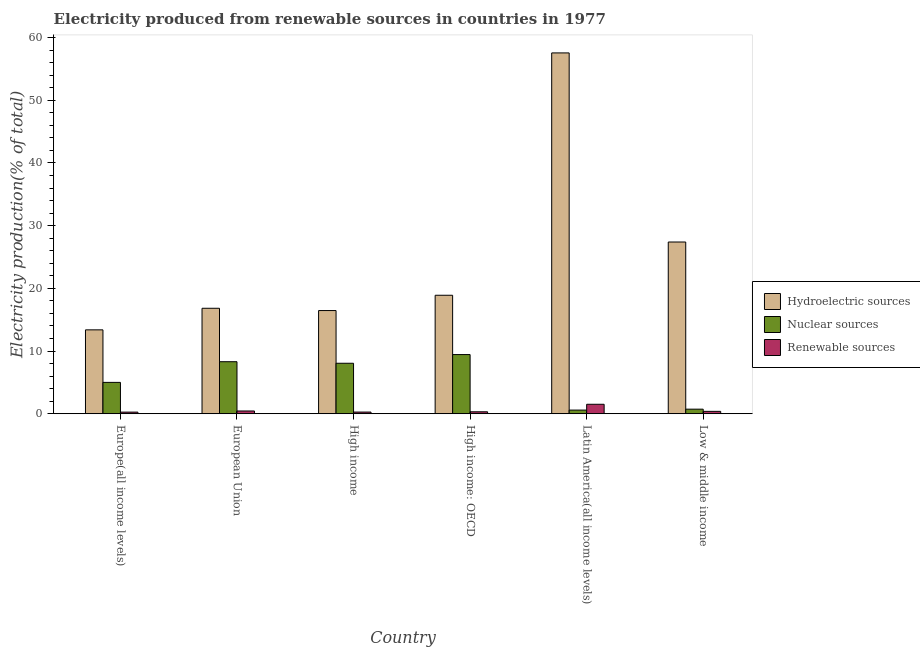How many different coloured bars are there?
Your answer should be compact. 3. How many groups of bars are there?
Keep it short and to the point. 6. Are the number of bars per tick equal to the number of legend labels?
Offer a very short reply. Yes. Are the number of bars on each tick of the X-axis equal?
Your answer should be very brief. Yes. How many bars are there on the 1st tick from the right?
Your answer should be very brief. 3. What is the label of the 5th group of bars from the left?
Make the answer very short. Latin America(all income levels). What is the percentage of electricity produced by nuclear sources in European Union?
Keep it short and to the point. 8.3. Across all countries, what is the maximum percentage of electricity produced by hydroelectric sources?
Offer a very short reply. 57.55. Across all countries, what is the minimum percentage of electricity produced by nuclear sources?
Your response must be concise. 0.58. In which country was the percentage of electricity produced by renewable sources maximum?
Provide a succinct answer. Latin America(all income levels). In which country was the percentage of electricity produced by renewable sources minimum?
Make the answer very short. Europe(all income levels). What is the total percentage of electricity produced by renewable sources in the graph?
Provide a succinct answer. 3.17. What is the difference between the percentage of electricity produced by nuclear sources in European Union and that in High income?
Offer a very short reply. 0.24. What is the difference between the percentage of electricity produced by nuclear sources in High income: OECD and the percentage of electricity produced by hydroelectric sources in Low & middle income?
Your answer should be very brief. -17.95. What is the average percentage of electricity produced by renewable sources per country?
Ensure brevity in your answer.  0.53. What is the difference between the percentage of electricity produced by renewable sources and percentage of electricity produced by nuclear sources in Europe(all income levels)?
Ensure brevity in your answer.  -4.74. What is the ratio of the percentage of electricity produced by hydroelectric sources in Europe(all income levels) to that in High income: OECD?
Your answer should be compact. 0.71. Is the percentage of electricity produced by nuclear sources in European Union less than that in High income: OECD?
Your response must be concise. Yes. What is the difference between the highest and the second highest percentage of electricity produced by renewable sources?
Offer a terse response. 1.07. What is the difference between the highest and the lowest percentage of electricity produced by hydroelectric sources?
Your answer should be very brief. 44.17. In how many countries, is the percentage of electricity produced by renewable sources greater than the average percentage of electricity produced by renewable sources taken over all countries?
Offer a terse response. 1. What does the 1st bar from the left in European Union represents?
Your answer should be very brief. Hydroelectric sources. What does the 1st bar from the right in Low & middle income represents?
Your answer should be very brief. Renewable sources. Is it the case that in every country, the sum of the percentage of electricity produced by hydroelectric sources and percentage of electricity produced by nuclear sources is greater than the percentage of electricity produced by renewable sources?
Your response must be concise. Yes. Are all the bars in the graph horizontal?
Your answer should be compact. No. How many countries are there in the graph?
Provide a succinct answer. 6. What is the difference between two consecutive major ticks on the Y-axis?
Your response must be concise. 10. Are the values on the major ticks of Y-axis written in scientific E-notation?
Provide a short and direct response. No. Where does the legend appear in the graph?
Offer a terse response. Center right. What is the title of the graph?
Make the answer very short. Electricity produced from renewable sources in countries in 1977. Does "Coal" appear as one of the legend labels in the graph?
Your answer should be compact. No. What is the label or title of the X-axis?
Make the answer very short. Country. What is the Electricity production(% of total) of Hydroelectric sources in Europe(all income levels)?
Provide a short and direct response. 13.38. What is the Electricity production(% of total) of Nuclear sources in Europe(all income levels)?
Your answer should be compact. 5. What is the Electricity production(% of total) of Renewable sources in Europe(all income levels)?
Give a very brief answer. 0.26. What is the Electricity production(% of total) in Hydroelectric sources in European Union?
Keep it short and to the point. 16.82. What is the Electricity production(% of total) in Nuclear sources in European Union?
Your response must be concise. 8.3. What is the Electricity production(% of total) in Renewable sources in European Union?
Ensure brevity in your answer.  0.44. What is the Electricity production(% of total) of Hydroelectric sources in High income?
Offer a terse response. 16.46. What is the Electricity production(% of total) in Nuclear sources in High income?
Give a very brief answer. 8.05. What is the Electricity production(% of total) of Renewable sources in High income?
Ensure brevity in your answer.  0.27. What is the Electricity production(% of total) in Hydroelectric sources in High income: OECD?
Provide a succinct answer. 18.9. What is the Electricity production(% of total) of Nuclear sources in High income: OECD?
Your answer should be very brief. 9.44. What is the Electricity production(% of total) in Renewable sources in High income: OECD?
Provide a short and direct response. 0.31. What is the Electricity production(% of total) in Hydroelectric sources in Latin America(all income levels)?
Your response must be concise. 57.55. What is the Electricity production(% of total) in Nuclear sources in Latin America(all income levels)?
Your answer should be very brief. 0.58. What is the Electricity production(% of total) in Renewable sources in Latin America(all income levels)?
Offer a very short reply. 1.51. What is the Electricity production(% of total) in Hydroelectric sources in Low & middle income?
Keep it short and to the point. 27.39. What is the Electricity production(% of total) of Nuclear sources in Low & middle income?
Keep it short and to the point. 0.73. What is the Electricity production(% of total) of Renewable sources in Low & middle income?
Your response must be concise. 0.38. Across all countries, what is the maximum Electricity production(% of total) in Hydroelectric sources?
Offer a terse response. 57.55. Across all countries, what is the maximum Electricity production(% of total) in Nuclear sources?
Make the answer very short. 9.44. Across all countries, what is the maximum Electricity production(% of total) in Renewable sources?
Keep it short and to the point. 1.51. Across all countries, what is the minimum Electricity production(% of total) of Hydroelectric sources?
Provide a short and direct response. 13.38. Across all countries, what is the minimum Electricity production(% of total) of Nuclear sources?
Give a very brief answer. 0.58. Across all countries, what is the minimum Electricity production(% of total) in Renewable sources?
Keep it short and to the point. 0.26. What is the total Electricity production(% of total) of Hydroelectric sources in the graph?
Your response must be concise. 150.49. What is the total Electricity production(% of total) of Nuclear sources in the graph?
Ensure brevity in your answer.  32.1. What is the total Electricity production(% of total) of Renewable sources in the graph?
Provide a succinct answer. 3.17. What is the difference between the Electricity production(% of total) in Hydroelectric sources in Europe(all income levels) and that in European Union?
Your answer should be compact. -3.44. What is the difference between the Electricity production(% of total) of Nuclear sources in Europe(all income levels) and that in European Union?
Provide a short and direct response. -3.3. What is the difference between the Electricity production(% of total) of Renewable sources in Europe(all income levels) and that in European Union?
Keep it short and to the point. -0.18. What is the difference between the Electricity production(% of total) of Hydroelectric sources in Europe(all income levels) and that in High income?
Provide a short and direct response. -3.08. What is the difference between the Electricity production(% of total) in Nuclear sources in Europe(all income levels) and that in High income?
Your response must be concise. -3.05. What is the difference between the Electricity production(% of total) in Renewable sources in Europe(all income levels) and that in High income?
Your answer should be compact. -0.01. What is the difference between the Electricity production(% of total) in Hydroelectric sources in Europe(all income levels) and that in High income: OECD?
Provide a short and direct response. -5.52. What is the difference between the Electricity production(% of total) of Nuclear sources in Europe(all income levels) and that in High income: OECD?
Provide a short and direct response. -4.44. What is the difference between the Electricity production(% of total) in Renewable sources in Europe(all income levels) and that in High income: OECD?
Your answer should be compact. -0.05. What is the difference between the Electricity production(% of total) of Hydroelectric sources in Europe(all income levels) and that in Latin America(all income levels)?
Ensure brevity in your answer.  -44.17. What is the difference between the Electricity production(% of total) in Nuclear sources in Europe(all income levels) and that in Latin America(all income levels)?
Your answer should be compact. 4.42. What is the difference between the Electricity production(% of total) in Renewable sources in Europe(all income levels) and that in Latin America(all income levels)?
Offer a terse response. -1.25. What is the difference between the Electricity production(% of total) in Hydroelectric sources in Europe(all income levels) and that in Low & middle income?
Make the answer very short. -14.01. What is the difference between the Electricity production(% of total) of Nuclear sources in Europe(all income levels) and that in Low & middle income?
Keep it short and to the point. 4.27. What is the difference between the Electricity production(% of total) of Renewable sources in Europe(all income levels) and that in Low & middle income?
Provide a succinct answer. -0.12. What is the difference between the Electricity production(% of total) of Hydroelectric sources in European Union and that in High income?
Provide a short and direct response. 0.36. What is the difference between the Electricity production(% of total) in Nuclear sources in European Union and that in High income?
Ensure brevity in your answer.  0.24. What is the difference between the Electricity production(% of total) of Renewable sources in European Union and that in High income?
Your response must be concise. 0.17. What is the difference between the Electricity production(% of total) in Hydroelectric sources in European Union and that in High income: OECD?
Make the answer very short. -2.08. What is the difference between the Electricity production(% of total) in Nuclear sources in European Union and that in High income: OECD?
Make the answer very short. -1.14. What is the difference between the Electricity production(% of total) of Renewable sources in European Union and that in High income: OECD?
Your answer should be very brief. 0.13. What is the difference between the Electricity production(% of total) in Hydroelectric sources in European Union and that in Latin America(all income levels)?
Your answer should be very brief. -40.73. What is the difference between the Electricity production(% of total) of Nuclear sources in European Union and that in Latin America(all income levels)?
Your answer should be compact. 7.71. What is the difference between the Electricity production(% of total) in Renewable sources in European Union and that in Latin America(all income levels)?
Your answer should be compact. -1.07. What is the difference between the Electricity production(% of total) in Hydroelectric sources in European Union and that in Low & middle income?
Make the answer very short. -10.57. What is the difference between the Electricity production(% of total) in Nuclear sources in European Union and that in Low & middle income?
Make the answer very short. 7.57. What is the difference between the Electricity production(% of total) in Renewable sources in European Union and that in Low & middle income?
Give a very brief answer. 0.06. What is the difference between the Electricity production(% of total) of Hydroelectric sources in High income and that in High income: OECD?
Provide a short and direct response. -2.44. What is the difference between the Electricity production(% of total) of Nuclear sources in High income and that in High income: OECD?
Your answer should be very brief. -1.39. What is the difference between the Electricity production(% of total) of Renewable sources in High income and that in High income: OECD?
Ensure brevity in your answer.  -0.05. What is the difference between the Electricity production(% of total) in Hydroelectric sources in High income and that in Latin America(all income levels)?
Offer a very short reply. -41.09. What is the difference between the Electricity production(% of total) of Nuclear sources in High income and that in Latin America(all income levels)?
Offer a very short reply. 7.47. What is the difference between the Electricity production(% of total) in Renewable sources in High income and that in Latin America(all income levels)?
Provide a succinct answer. -1.24. What is the difference between the Electricity production(% of total) of Hydroelectric sources in High income and that in Low & middle income?
Give a very brief answer. -10.93. What is the difference between the Electricity production(% of total) in Nuclear sources in High income and that in Low & middle income?
Your response must be concise. 7.32. What is the difference between the Electricity production(% of total) in Renewable sources in High income and that in Low & middle income?
Your response must be concise. -0.11. What is the difference between the Electricity production(% of total) in Hydroelectric sources in High income: OECD and that in Latin America(all income levels)?
Give a very brief answer. -38.65. What is the difference between the Electricity production(% of total) of Nuclear sources in High income: OECD and that in Latin America(all income levels)?
Provide a succinct answer. 8.86. What is the difference between the Electricity production(% of total) of Renewable sources in High income: OECD and that in Latin America(all income levels)?
Offer a very short reply. -1.2. What is the difference between the Electricity production(% of total) in Hydroelectric sources in High income: OECD and that in Low & middle income?
Keep it short and to the point. -8.49. What is the difference between the Electricity production(% of total) of Nuclear sources in High income: OECD and that in Low & middle income?
Provide a short and direct response. 8.71. What is the difference between the Electricity production(% of total) in Renewable sources in High income: OECD and that in Low & middle income?
Ensure brevity in your answer.  -0.07. What is the difference between the Electricity production(% of total) in Hydroelectric sources in Latin America(all income levels) and that in Low & middle income?
Offer a very short reply. 30.16. What is the difference between the Electricity production(% of total) in Nuclear sources in Latin America(all income levels) and that in Low & middle income?
Your answer should be compact. -0.15. What is the difference between the Electricity production(% of total) of Renewable sources in Latin America(all income levels) and that in Low & middle income?
Keep it short and to the point. 1.13. What is the difference between the Electricity production(% of total) of Hydroelectric sources in Europe(all income levels) and the Electricity production(% of total) of Nuclear sources in European Union?
Your answer should be compact. 5.08. What is the difference between the Electricity production(% of total) in Hydroelectric sources in Europe(all income levels) and the Electricity production(% of total) in Renewable sources in European Union?
Your response must be concise. 12.94. What is the difference between the Electricity production(% of total) in Nuclear sources in Europe(all income levels) and the Electricity production(% of total) in Renewable sources in European Union?
Make the answer very short. 4.56. What is the difference between the Electricity production(% of total) in Hydroelectric sources in Europe(all income levels) and the Electricity production(% of total) in Nuclear sources in High income?
Ensure brevity in your answer.  5.33. What is the difference between the Electricity production(% of total) in Hydroelectric sources in Europe(all income levels) and the Electricity production(% of total) in Renewable sources in High income?
Give a very brief answer. 13.11. What is the difference between the Electricity production(% of total) in Nuclear sources in Europe(all income levels) and the Electricity production(% of total) in Renewable sources in High income?
Your answer should be compact. 4.73. What is the difference between the Electricity production(% of total) of Hydroelectric sources in Europe(all income levels) and the Electricity production(% of total) of Nuclear sources in High income: OECD?
Your answer should be compact. 3.94. What is the difference between the Electricity production(% of total) of Hydroelectric sources in Europe(all income levels) and the Electricity production(% of total) of Renewable sources in High income: OECD?
Provide a short and direct response. 13.07. What is the difference between the Electricity production(% of total) of Nuclear sources in Europe(all income levels) and the Electricity production(% of total) of Renewable sources in High income: OECD?
Keep it short and to the point. 4.69. What is the difference between the Electricity production(% of total) of Hydroelectric sources in Europe(all income levels) and the Electricity production(% of total) of Nuclear sources in Latin America(all income levels)?
Give a very brief answer. 12.8. What is the difference between the Electricity production(% of total) of Hydroelectric sources in Europe(all income levels) and the Electricity production(% of total) of Renewable sources in Latin America(all income levels)?
Ensure brevity in your answer.  11.87. What is the difference between the Electricity production(% of total) in Nuclear sources in Europe(all income levels) and the Electricity production(% of total) in Renewable sources in Latin America(all income levels)?
Give a very brief answer. 3.49. What is the difference between the Electricity production(% of total) in Hydroelectric sources in Europe(all income levels) and the Electricity production(% of total) in Nuclear sources in Low & middle income?
Ensure brevity in your answer.  12.65. What is the difference between the Electricity production(% of total) of Hydroelectric sources in Europe(all income levels) and the Electricity production(% of total) of Renewable sources in Low & middle income?
Keep it short and to the point. 13. What is the difference between the Electricity production(% of total) in Nuclear sources in Europe(all income levels) and the Electricity production(% of total) in Renewable sources in Low & middle income?
Your response must be concise. 4.62. What is the difference between the Electricity production(% of total) in Hydroelectric sources in European Union and the Electricity production(% of total) in Nuclear sources in High income?
Provide a succinct answer. 8.77. What is the difference between the Electricity production(% of total) of Hydroelectric sources in European Union and the Electricity production(% of total) of Renewable sources in High income?
Your response must be concise. 16.55. What is the difference between the Electricity production(% of total) of Nuclear sources in European Union and the Electricity production(% of total) of Renewable sources in High income?
Make the answer very short. 8.03. What is the difference between the Electricity production(% of total) of Hydroelectric sources in European Union and the Electricity production(% of total) of Nuclear sources in High income: OECD?
Your response must be concise. 7.38. What is the difference between the Electricity production(% of total) of Hydroelectric sources in European Union and the Electricity production(% of total) of Renewable sources in High income: OECD?
Ensure brevity in your answer.  16.51. What is the difference between the Electricity production(% of total) of Nuclear sources in European Union and the Electricity production(% of total) of Renewable sources in High income: OECD?
Ensure brevity in your answer.  7.99. What is the difference between the Electricity production(% of total) in Hydroelectric sources in European Union and the Electricity production(% of total) in Nuclear sources in Latin America(all income levels)?
Your answer should be very brief. 16.24. What is the difference between the Electricity production(% of total) of Hydroelectric sources in European Union and the Electricity production(% of total) of Renewable sources in Latin America(all income levels)?
Make the answer very short. 15.31. What is the difference between the Electricity production(% of total) in Nuclear sources in European Union and the Electricity production(% of total) in Renewable sources in Latin America(all income levels)?
Offer a terse response. 6.79. What is the difference between the Electricity production(% of total) of Hydroelectric sources in European Union and the Electricity production(% of total) of Nuclear sources in Low & middle income?
Provide a short and direct response. 16.09. What is the difference between the Electricity production(% of total) in Hydroelectric sources in European Union and the Electricity production(% of total) in Renewable sources in Low & middle income?
Provide a succinct answer. 16.44. What is the difference between the Electricity production(% of total) in Nuclear sources in European Union and the Electricity production(% of total) in Renewable sources in Low & middle income?
Provide a succinct answer. 7.92. What is the difference between the Electricity production(% of total) of Hydroelectric sources in High income and the Electricity production(% of total) of Nuclear sources in High income: OECD?
Offer a very short reply. 7.02. What is the difference between the Electricity production(% of total) of Hydroelectric sources in High income and the Electricity production(% of total) of Renewable sources in High income: OECD?
Your answer should be compact. 16.15. What is the difference between the Electricity production(% of total) of Nuclear sources in High income and the Electricity production(% of total) of Renewable sources in High income: OECD?
Your answer should be compact. 7.74. What is the difference between the Electricity production(% of total) in Hydroelectric sources in High income and the Electricity production(% of total) in Nuclear sources in Latin America(all income levels)?
Give a very brief answer. 15.87. What is the difference between the Electricity production(% of total) in Hydroelectric sources in High income and the Electricity production(% of total) in Renewable sources in Latin America(all income levels)?
Your answer should be very brief. 14.95. What is the difference between the Electricity production(% of total) in Nuclear sources in High income and the Electricity production(% of total) in Renewable sources in Latin America(all income levels)?
Offer a very short reply. 6.54. What is the difference between the Electricity production(% of total) in Hydroelectric sources in High income and the Electricity production(% of total) in Nuclear sources in Low & middle income?
Your answer should be very brief. 15.73. What is the difference between the Electricity production(% of total) in Hydroelectric sources in High income and the Electricity production(% of total) in Renewable sources in Low & middle income?
Give a very brief answer. 16.08. What is the difference between the Electricity production(% of total) of Nuclear sources in High income and the Electricity production(% of total) of Renewable sources in Low & middle income?
Provide a succinct answer. 7.67. What is the difference between the Electricity production(% of total) of Hydroelectric sources in High income: OECD and the Electricity production(% of total) of Nuclear sources in Latin America(all income levels)?
Your response must be concise. 18.31. What is the difference between the Electricity production(% of total) in Hydroelectric sources in High income: OECD and the Electricity production(% of total) in Renewable sources in Latin America(all income levels)?
Offer a terse response. 17.39. What is the difference between the Electricity production(% of total) in Nuclear sources in High income: OECD and the Electricity production(% of total) in Renewable sources in Latin America(all income levels)?
Make the answer very short. 7.93. What is the difference between the Electricity production(% of total) of Hydroelectric sources in High income: OECD and the Electricity production(% of total) of Nuclear sources in Low & middle income?
Make the answer very short. 18.17. What is the difference between the Electricity production(% of total) of Hydroelectric sources in High income: OECD and the Electricity production(% of total) of Renewable sources in Low & middle income?
Your answer should be compact. 18.52. What is the difference between the Electricity production(% of total) of Nuclear sources in High income: OECD and the Electricity production(% of total) of Renewable sources in Low & middle income?
Your response must be concise. 9.06. What is the difference between the Electricity production(% of total) of Hydroelectric sources in Latin America(all income levels) and the Electricity production(% of total) of Nuclear sources in Low & middle income?
Provide a short and direct response. 56.82. What is the difference between the Electricity production(% of total) of Hydroelectric sources in Latin America(all income levels) and the Electricity production(% of total) of Renewable sources in Low & middle income?
Offer a very short reply. 57.17. What is the difference between the Electricity production(% of total) in Nuclear sources in Latin America(all income levels) and the Electricity production(% of total) in Renewable sources in Low & middle income?
Give a very brief answer. 0.2. What is the average Electricity production(% of total) in Hydroelectric sources per country?
Provide a short and direct response. 25.08. What is the average Electricity production(% of total) in Nuclear sources per country?
Make the answer very short. 5.35. What is the average Electricity production(% of total) of Renewable sources per country?
Ensure brevity in your answer.  0.53. What is the difference between the Electricity production(% of total) in Hydroelectric sources and Electricity production(% of total) in Nuclear sources in Europe(all income levels)?
Make the answer very short. 8.38. What is the difference between the Electricity production(% of total) of Hydroelectric sources and Electricity production(% of total) of Renewable sources in Europe(all income levels)?
Provide a short and direct response. 13.12. What is the difference between the Electricity production(% of total) in Nuclear sources and Electricity production(% of total) in Renewable sources in Europe(all income levels)?
Give a very brief answer. 4.74. What is the difference between the Electricity production(% of total) in Hydroelectric sources and Electricity production(% of total) in Nuclear sources in European Union?
Your answer should be very brief. 8.52. What is the difference between the Electricity production(% of total) of Hydroelectric sources and Electricity production(% of total) of Renewable sources in European Union?
Your answer should be compact. 16.38. What is the difference between the Electricity production(% of total) of Nuclear sources and Electricity production(% of total) of Renewable sources in European Union?
Provide a succinct answer. 7.86. What is the difference between the Electricity production(% of total) in Hydroelectric sources and Electricity production(% of total) in Nuclear sources in High income?
Provide a succinct answer. 8.4. What is the difference between the Electricity production(% of total) in Hydroelectric sources and Electricity production(% of total) in Renewable sources in High income?
Your response must be concise. 16.19. What is the difference between the Electricity production(% of total) in Nuclear sources and Electricity production(% of total) in Renewable sources in High income?
Your response must be concise. 7.79. What is the difference between the Electricity production(% of total) in Hydroelectric sources and Electricity production(% of total) in Nuclear sources in High income: OECD?
Make the answer very short. 9.46. What is the difference between the Electricity production(% of total) of Hydroelectric sources and Electricity production(% of total) of Renewable sources in High income: OECD?
Offer a terse response. 18.59. What is the difference between the Electricity production(% of total) in Nuclear sources and Electricity production(% of total) in Renewable sources in High income: OECD?
Keep it short and to the point. 9.13. What is the difference between the Electricity production(% of total) in Hydroelectric sources and Electricity production(% of total) in Nuclear sources in Latin America(all income levels)?
Provide a succinct answer. 56.97. What is the difference between the Electricity production(% of total) of Hydroelectric sources and Electricity production(% of total) of Renewable sources in Latin America(all income levels)?
Offer a terse response. 56.04. What is the difference between the Electricity production(% of total) in Nuclear sources and Electricity production(% of total) in Renewable sources in Latin America(all income levels)?
Provide a short and direct response. -0.93. What is the difference between the Electricity production(% of total) of Hydroelectric sources and Electricity production(% of total) of Nuclear sources in Low & middle income?
Ensure brevity in your answer.  26.66. What is the difference between the Electricity production(% of total) of Hydroelectric sources and Electricity production(% of total) of Renewable sources in Low & middle income?
Provide a succinct answer. 27.01. What is the difference between the Electricity production(% of total) of Nuclear sources and Electricity production(% of total) of Renewable sources in Low & middle income?
Provide a short and direct response. 0.35. What is the ratio of the Electricity production(% of total) of Hydroelectric sources in Europe(all income levels) to that in European Union?
Offer a terse response. 0.8. What is the ratio of the Electricity production(% of total) of Nuclear sources in Europe(all income levels) to that in European Union?
Offer a very short reply. 0.6. What is the ratio of the Electricity production(% of total) in Renewable sources in Europe(all income levels) to that in European Union?
Make the answer very short. 0.59. What is the ratio of the Electricity production(% of total) of Hydroelectric sources in Europe(all income levels) to that in High income?
Your response must be concise. 0.81. What is the ratio of the Electricity production(% of total) in Nuclear sources in Europe(all income levels) to that in High income?
Your answer should be compact. 0.62. What is the ratio of the Electricity production(% of total) in Renewable sources in Europe(all income levels) to that in High income?
Give a very brief answer. 0.97. What is the ratio of the Electricity production(% of total) of Hydroelectric sources in Europe(all income levels) to that in High income: OECD?
Make the answer very short. 0.71. What is the ratio of the Electricity production(% of total) of Nuclear sources in Europe(all income levels) to that in High income: OECD?
Ensure brevity in your answer.  0.53. What is the ratio of the Electricity production(% of total) in Renewable sources in Europe(all income levels) to that in High income: OECD?
Your response must be concise. 0.83. What is the ratio of the Electricity production(% of total) of Hydroelectric sources in Europe(all income levels) to that in Latin America(all income levels)?
Your answer should be compact. 0.23. What is the ratio of the Electricity production(% of total) of Nuclear sources in Europe(all income levels) to that in Latin America(all income levels)?
Provide a succinct answer. 8.58. What is the ratio of the Electricity production(% of total) of Renewable sources in Europe(all income levels) to that in Latin America(all income levels)?
Your answer should be compact. 0.17. What is the ratio of the Electricity production(% of total) in Hydroelectric sources in Europe(all income levels) to that in Low & middle income?
Keep it short and to the point. 0.49. What is the ratio of the Electricity production(% of total) of Nuclear sources in Europe(all income levels) to that in Low & middle income?
Your response must be concise. 6.84. What is the ratio of the Electricity production(% of total) of Renewable sources in Europe(all income levels) to that in Low & middle income?
Provide a succinct answer. 0.68. What is the ratio of the Electricity production(% of total) of Hydroelectric sources in European Union to that in High income?
Your answer should be compact. 1.02. What is the ratio of the Electricity production(% of total) in Nuclear sources in European Union to that in High income?
Make the answer very short. 1.03. What is the ratio of the Electricity production(% of total) of Renewable sources in European Union to that in High income?
Offer a very short reply. 1.65. What is the ratio of the Electricity production(% of total) in Hydroelectric sources in European Union to that in High income: OECD?
Your response must be concise. 0.89. What is the ratio of the Electricity production(% of total) of Nuclear sources in European Union to that in High income: OECD?
Make the answer very short. 0.88. What is the ratio of the Electricity production(% of total) in Renewable sources in European Union to that in High income: OECD?
Offer a terse response. 1.41. What is the ratio of the Electricity production(% of total) in Hydroelectric sources in European Union to that in Latin America(all income levels)?
Keep it short and to the point. 0.29. What is the ratio of the Electricity production(% of total) in Nuclear sources in European Union to that in Latin America(all income levels)?
Keep it short and to the point. 14.23. What is the ratio of the Electricity production(% of total) in Renewable sources in European Union to that in Latin America(all income levels)?
Keep it short and to the point. 0.29. What is the ratio of the Electricity production(% of total) of Hydroelectric sources in European Union to that in Low & middle income?
Your answer should be compact. 0.61. What is the ratio of the Electricity production(% of total) in Nuclear sources in European Union to that in Low & middle income?
Keep it short and to the point. 11.35. What is the ratio of the Electricity production(% of total) in Renewable sources in European Union to that in Low & middle income?
Your answer should be very brief. 1.16. What is the ratio of the Electricity production(% of total) in Hydroelectric sources in High income to that in High income: OECD?
Provide a succinct answer. 0.87. What is the ratio of the Electricity production(% of total) of Nuclear sources in High income to that in High income: OECD?
Ensure brevity in your answer.  0.85. What is the ratio of the Electricity production(% of total) of Renewable sources in High income to that in High income: OECD?
Make the answer very short. 0.86. What is the ratio of the Electricity production(% of total) in Hydroelectric sources in High income to that in Latin America(all income levels)?
Provide a succinct answer. 0.29. What is the ratio of the Electricity production(% of total) in Nuclear sources in High income to that in Latin America(all income levels)?
Provide a short and direct response. 13.81. What is the ratio of the Electricity production(% of total) of Renewable sources in High income to that in Latin America(all income levels)?
Offer a terse response. 0.18. What is the ratio of the Electricity production(% of total) in Hydroelectric sources in High income to that in Low & middle income?
Offer a very short reply. 0.6. What is the ratio of the Electricity production(% of total) of Nuclear sources in High income to that in Low & middle income?
Offer a terse response. 11.02. What is the ratio of the Electricity production(% of total) in Renewable sources in High income to that in Low & middle income?
Keep it short and to the point. 0.7. What is the ratio of the Electricity production(% of total) of Hydroelectric sources in High income: OECD to that in Latin America(all income levels)?
Your response must be concise. 0.33. What is the ratio of the Electricity production(% of total) in Nuclear sources in High income: OECD to that in Latin America(all income levels)?
Ensure brevity in your answer.  16.19. What is the ratio of the Electricity production(% of total) in Renewable sources in High income: OECD to that in Latin America(all income levels)?
Make the answer very short. 0.21. What is the ratio of the Electricity production(% of total) of Hydroelectric sources in High income: OECD to that in Low & middle income?
Keep it short and to the point. 0.69. What is the ratio of the Electricity production(% of total) in Nuclear sources in High income: OECD to that in Low & middle income?
Your answer should be compact. 12.92. What is the ratio of the Electricity production(% of total) of Renewable sources in High income: OECD to that in Low & middle income?
Give a very brief answer. 0.82. What is the ratio of the Electricity production(% of total) of Hydroelectric sources in Latin America(all income levels) to that in Low & middle income?
Ensure brevity in your answer.  2.1. What is the ratio of the Electricity production(% of total) in Nuclear sources in Latin America(all income levels) to that in Low & middle income?
Provide a succinct answer. 0.8. What is the ratio of the Electricity production(% of total) of Renewable sources in Latin America(all income levels) to that in Low & middle income?
Your answer should be compact. 3.96. What is the difference between the highest and the second highest Electricity production(% of total) of Hydroelectric sources?
Make the answer very short. 30.16. What is the difference between the highest and the second highest Electricity production(% of total) of Nuclear sources?
Your answer should be very brief. 1.14. What is the difference between the highest and the second highest Electricity production(% of total) in Renewable sources?
Ensure brevity in your answer.  1.07. What is the difference between the highest and the lowest Electricity production(% of total) in Hydroelectric sources?
Offer a terse response. 44.17. What is the difference between the highest and the lowest Electricity production(% of total) in Nuclear sources?
Your answer should be compact. 8.86. What is the difference between the highest and the lowest Electricity production(% of total) of Renewable sources?
Your answer should be very brief. 1.25. 